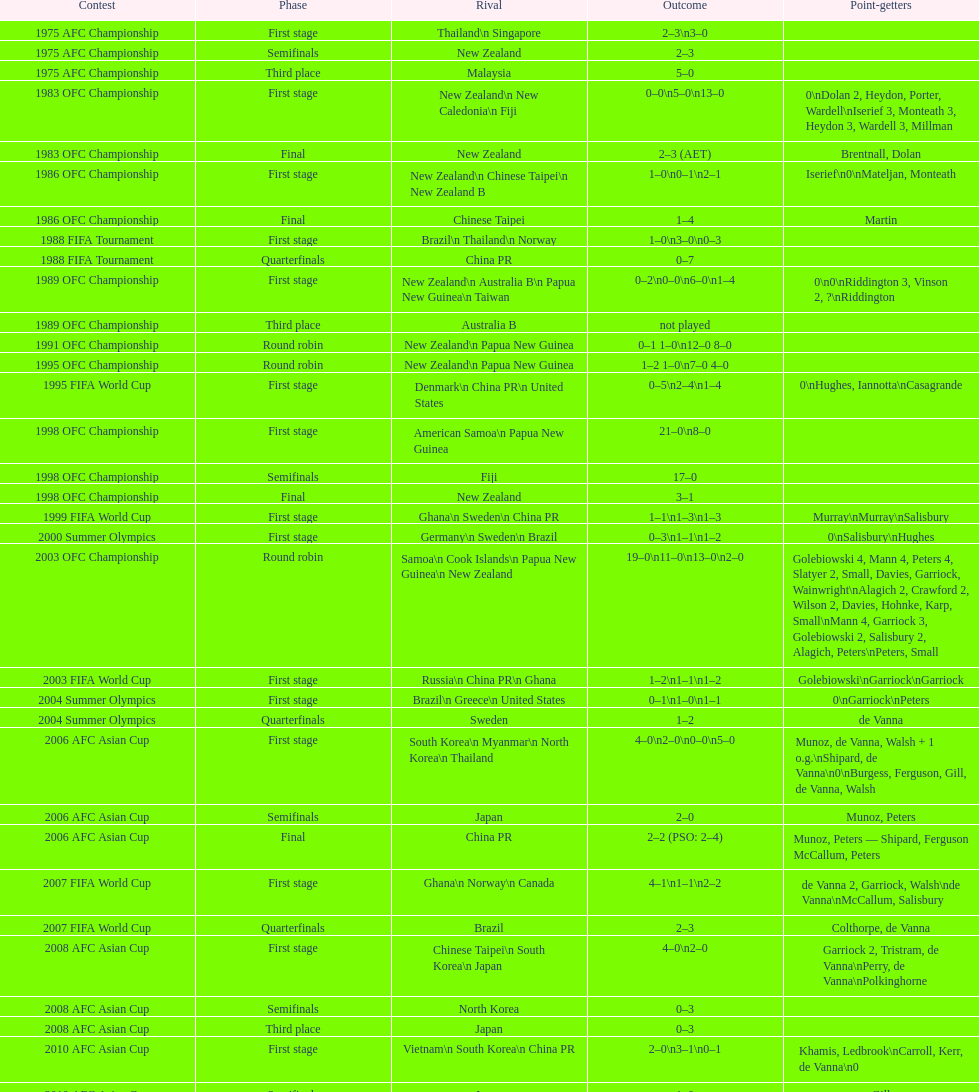What was the total goals made in the 1983 ofc championship? 18. 